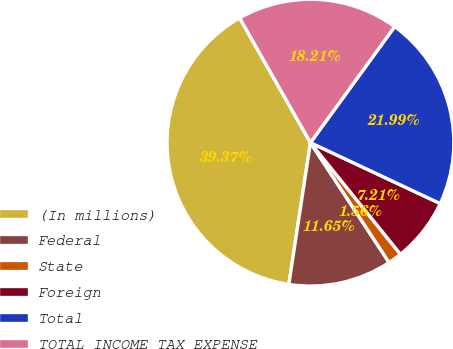Convert chart to OTSL. <chart><loc_0><loc_0><loc_500><loc_500><pie_chart><fcel>(In millions)<fcel>Federal<fcel>State<fcel>Foreign<fcel>Total<fcel>TOTAL INCOME TAX EXPENSE<nl><fcel>39.37%<fcel>11.65%<fcel>1.56%<fcel>7.21%<fcel>21.99%<fcel>18.21%<nl></chart> 